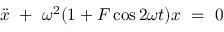<formula> <loc_0><loc_0><loc_500><loc_500>\ D d o t { x } \ + \ \omega ^ { 2 } ( 1 + F \cos 2 \omega t ) x \ = \ 0</formula> 